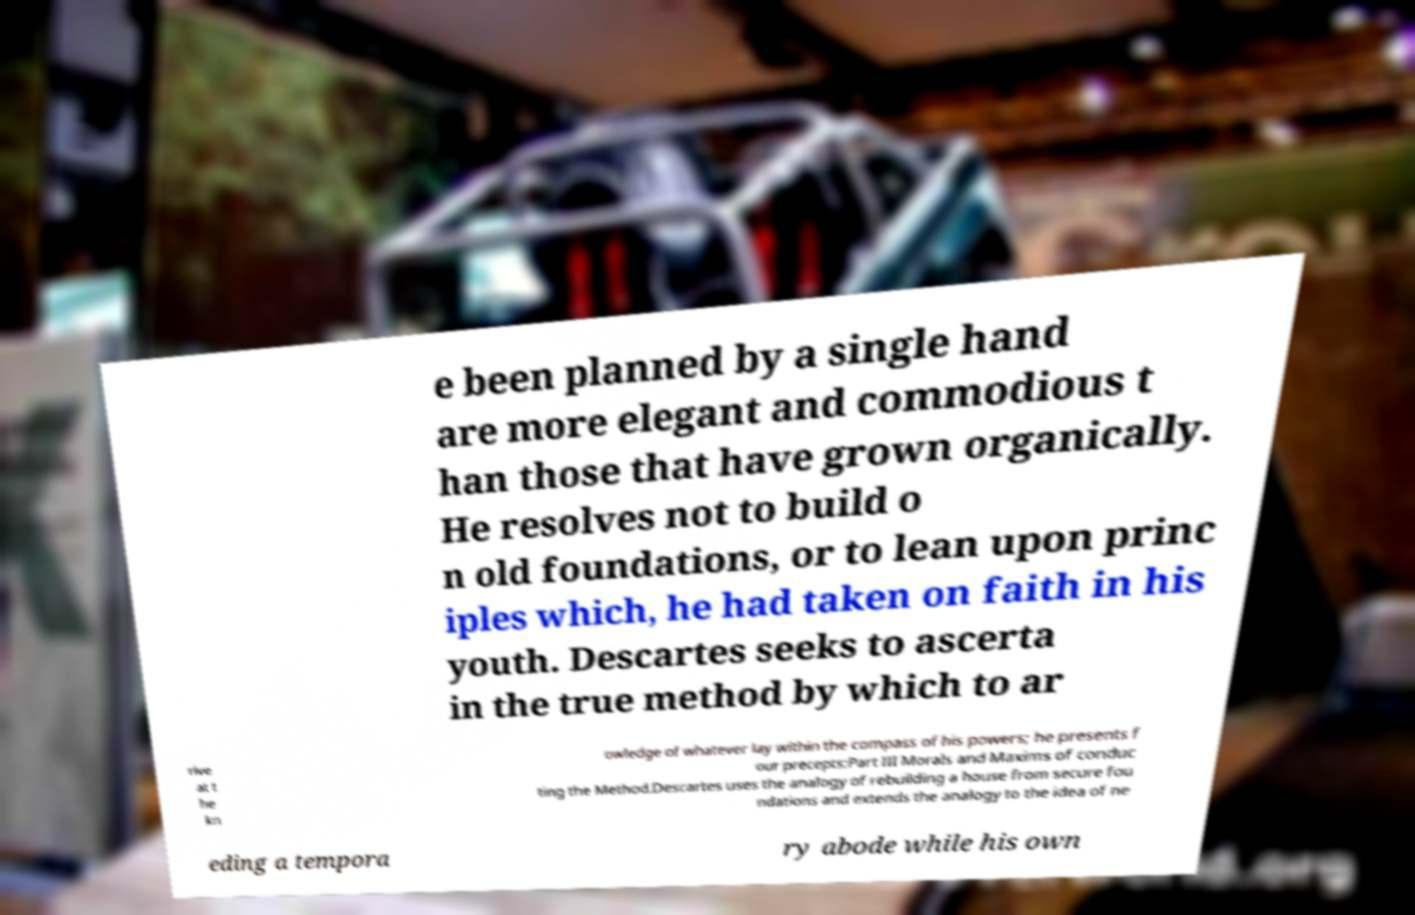For documentation purposes, I need the text within this image transcribed. Could you provide that? e been planned by a single hand are more elegant and commodious t han those that have grown organically. He resolves not to build o n old foundations, or to lean upon princ iples which, he had taken on faith in his youth. Descartes seeks to ascerta in the true method by which to ar rive at t he kn owledge of whatever lay within the compass of his powers; he presents f our precepts:Part III Morals and Maxims of conduc ting the Method.Descartes uses the analogy of rebuilding a house from secure fou ndations and extends the analogy to the idea of ne eding a tempora ry abode while his own 